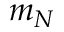<formula> <loc_0><loc_0><loc_500><loc_500>m _ { N }</formula> 